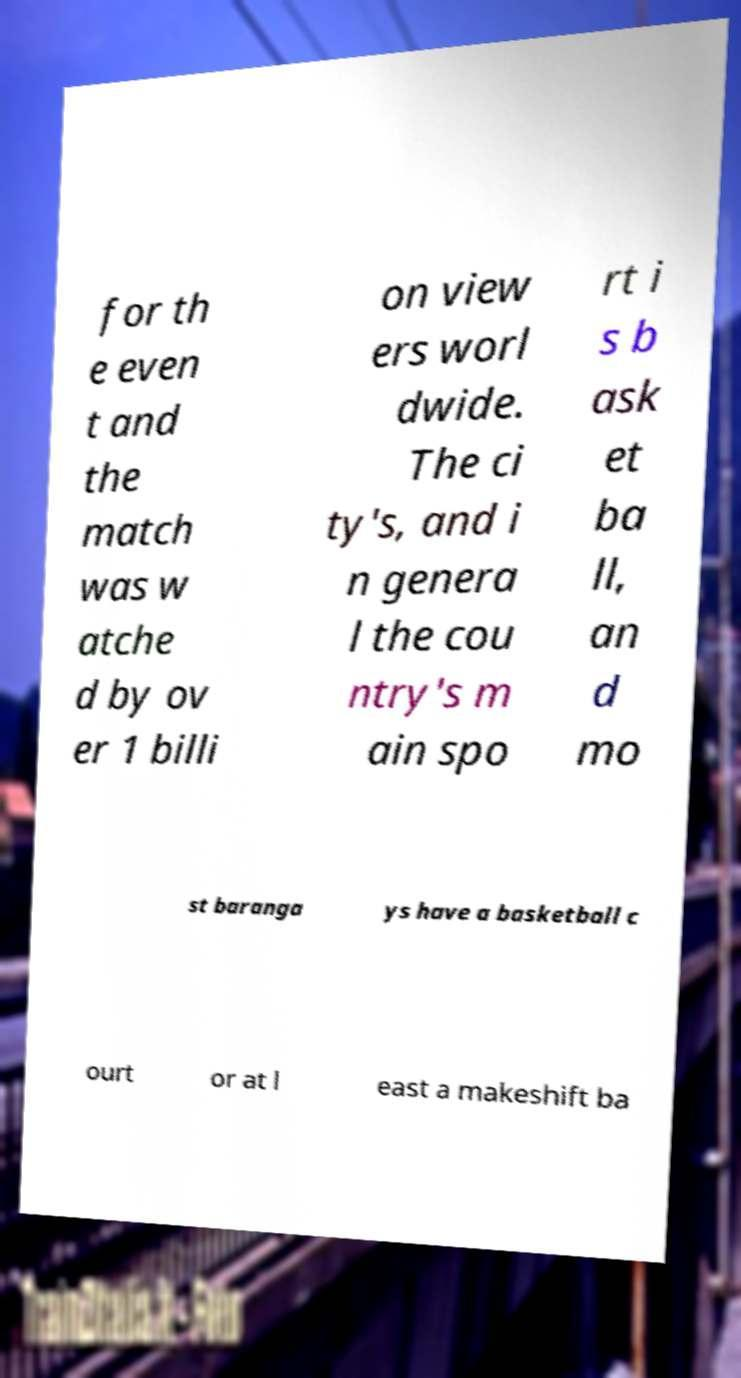Could you extract and type out the text from this image? for th e even t and the match was w atche d by ov er 1 billi on view ers worl dwide. The ci ty's, and i n genera l the cou ntry's m ain spo rt i s b ask et ba ll, an d mo st baranga ys have a basketball c ourt or at l east a makeshift ba 